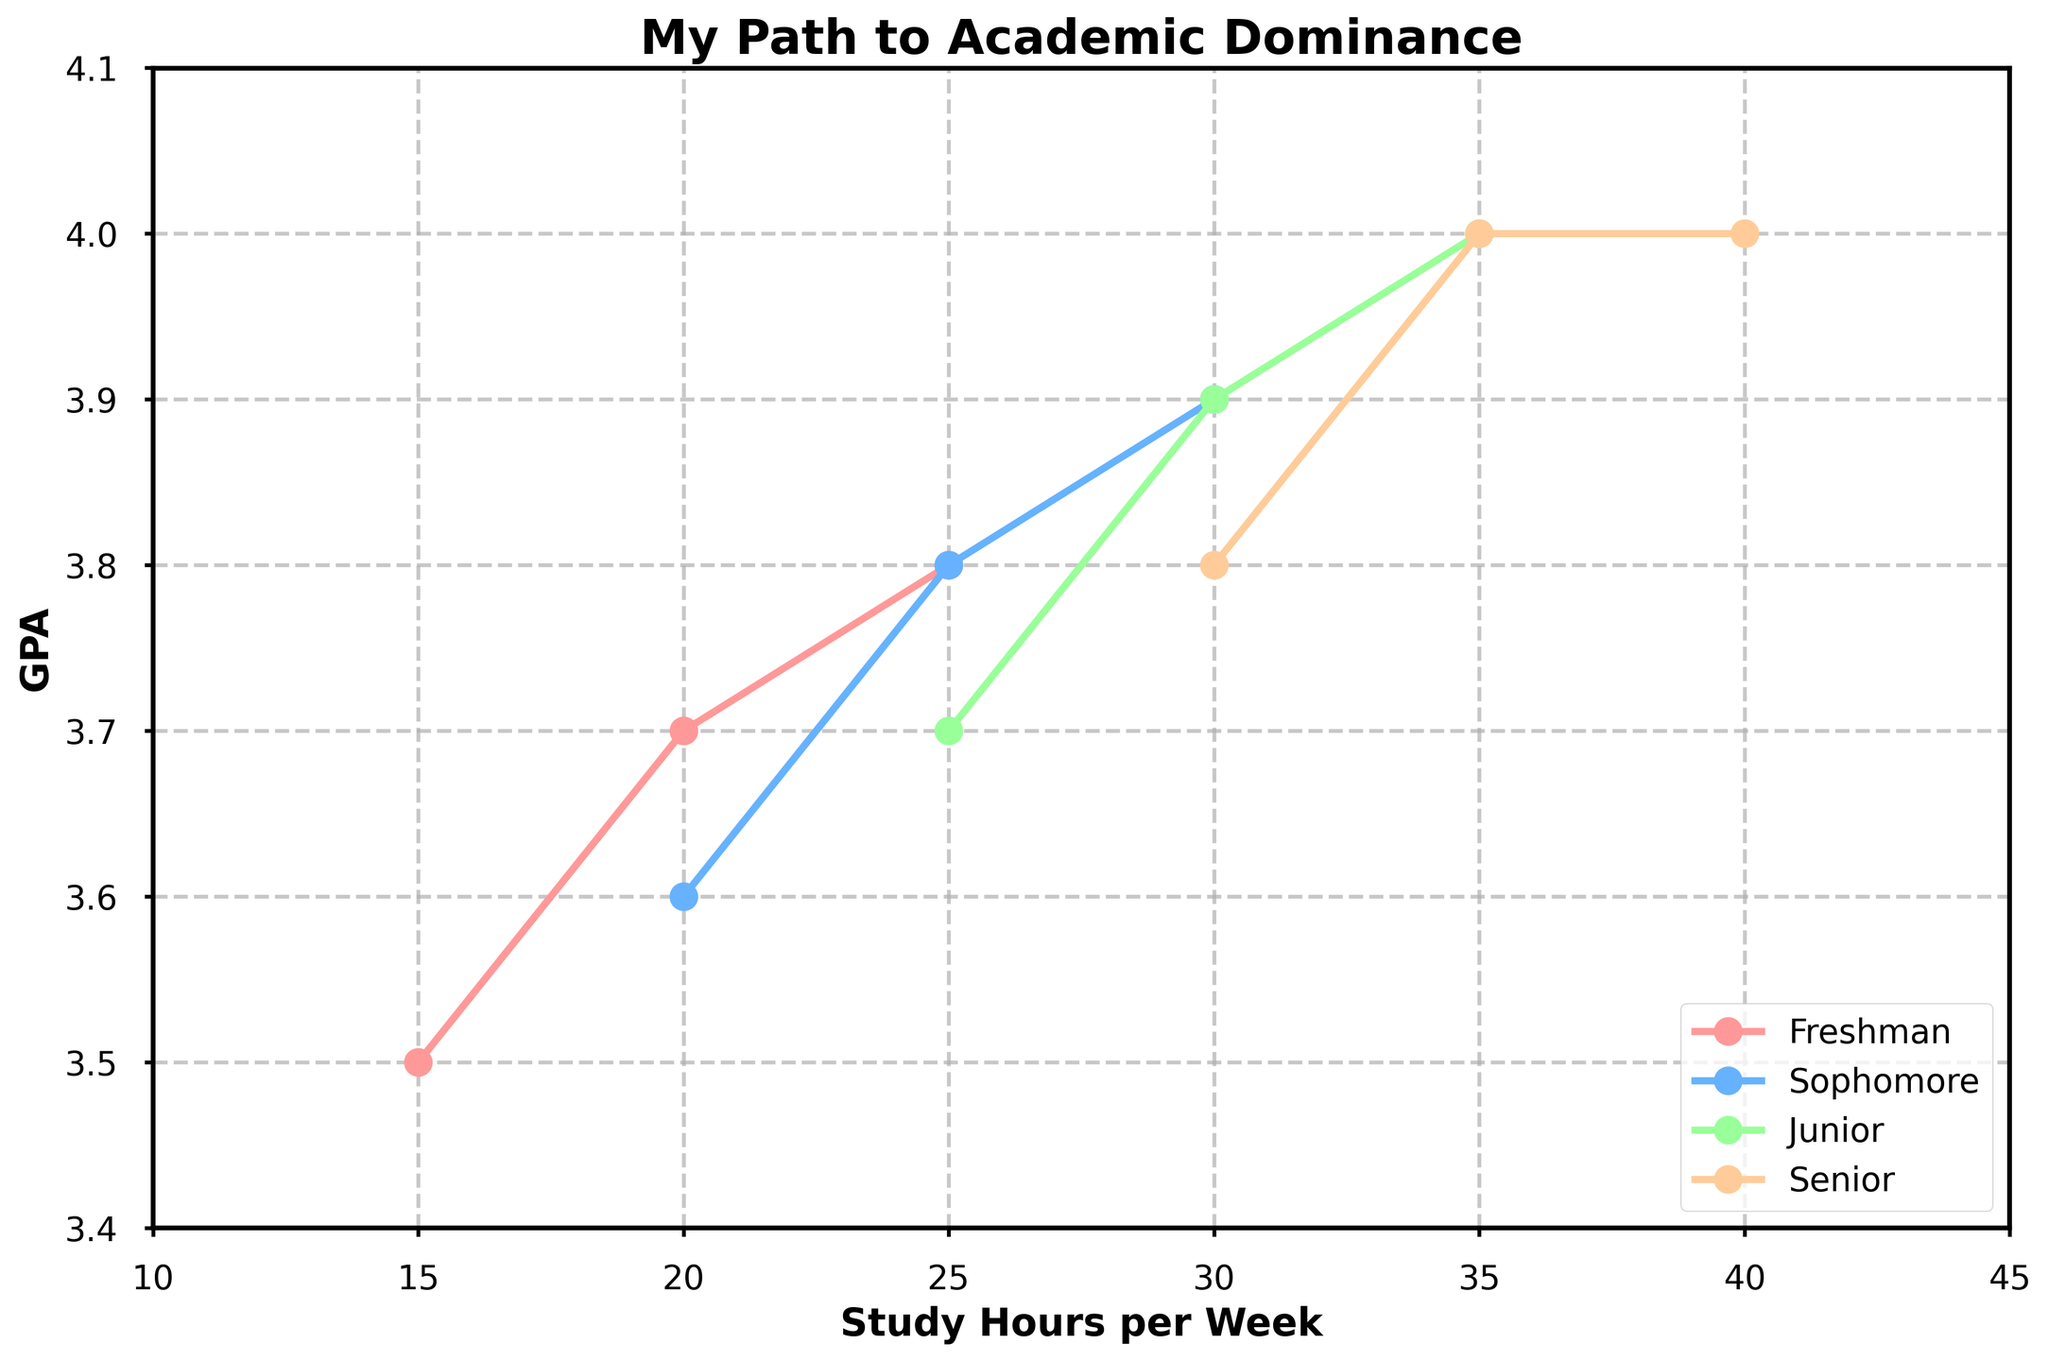What is the GPA for 25 study hours per week in the Freshman year? Look at the data point where the study hours per week are 25 for the Freshman year; the corresponding GPA is shown as 3.8
Answer: 3.8 Between which years does the biggest increase in GPA occur when study hours per week reach 30? Compare the GPA at 30 study hours per week across different years; Sophomore year is 3.9, Junior year is 3.9, and Senior year is 4.0. The biggest increase occurs from Junior to Senior year (3.9 to 4.0).
Answer: Junior to Senior In which year did the student achieve the highest GPA? Look for the highest GPA value across all years and find the year it corresponds to, which is 4.0. This occurs in Junior and Senior years.
Answer: Junior, Senior How does the GPA change from 15 to 40 study hours per week in the Senior year? Trace the GPA changes for the Senior year data points as the study hour changes: 30 hours (3.8) to 35 hours (4.0) to 40 hours (4.0). As study hours increase, the GPA also increases and then plateaus.
Answer: Increases, then plateaus Which year shows a consistent straight-line relationship between study hours and GPA? Examine the trend lines for each year. The line for the Junior year shows a consistently increasing straight-line relationship.
Answer: Junior Comparing Freshman and Sophomore years, which one shows more growth in GPA with increasing study hours? Look at the slope of the lines representing the GPA growth for each year. The slope for the Sophomore year is steeper than the Freshman year, indicating more growth in GPA with increasing study hours.
Answer: Sophomore What is the color used to represent the Junior year data? Identify the color used for the Junior year's line on the figure, which can be seen directly as blue.
Answer: Blue Which year has the minimum GPA value, and what is that value? Find the data point with the lowest GPA across all years, which is the Freshman year, 15 hours per week, with a GPA of 3.5.
Answer: Freshman, 3.5 If a student studies 30 hours per week, what is the range of GPAs they could achieve over the four years? Identify the GPA values for 30 study hours per week across each year: Sophomore (3.9), Junior (3.9), Senior (4.0), so the range is from 3.9 to 4.0.
Answer: 3.9 to 4.0 